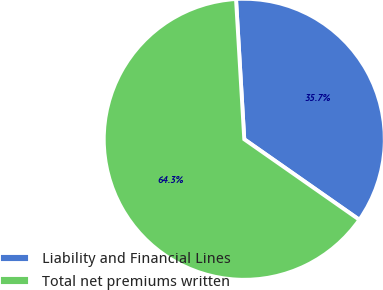Convert chart to OTSL. <chart><loc_0><loc_0><loc_500><loc_500><pie_chart><fcel>Liability and Financial Lines<fcel>Total net premiums written<nl><fcel>35.65%<fcel>64.35%<nl></chart> 